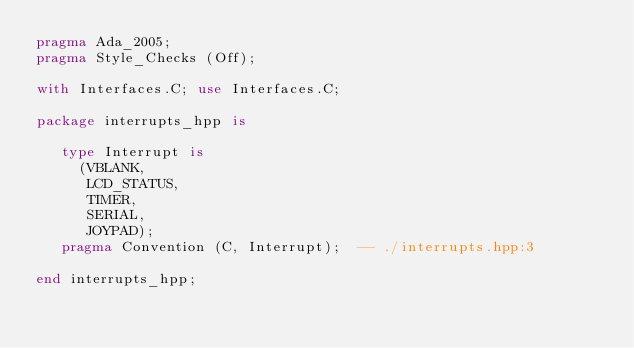Convert code to text. <code><loc_0><loc_0><loc_500><loc_500><_Ada_>pragma Ada_2005;
pragma Style_Checks (Off);

with Interfaces.C; use Interfaces.C;

package interrupts_hpp is

   type Interrupt is 
     (VBLANK,
      LCD_STATUS,
      TIMER,
      SERIAL,
      JOYPAD);
   pragma Convention (C, Interrupt);  -- ./interrupts.hpp:3

end interrupts_hpp;
</code> 